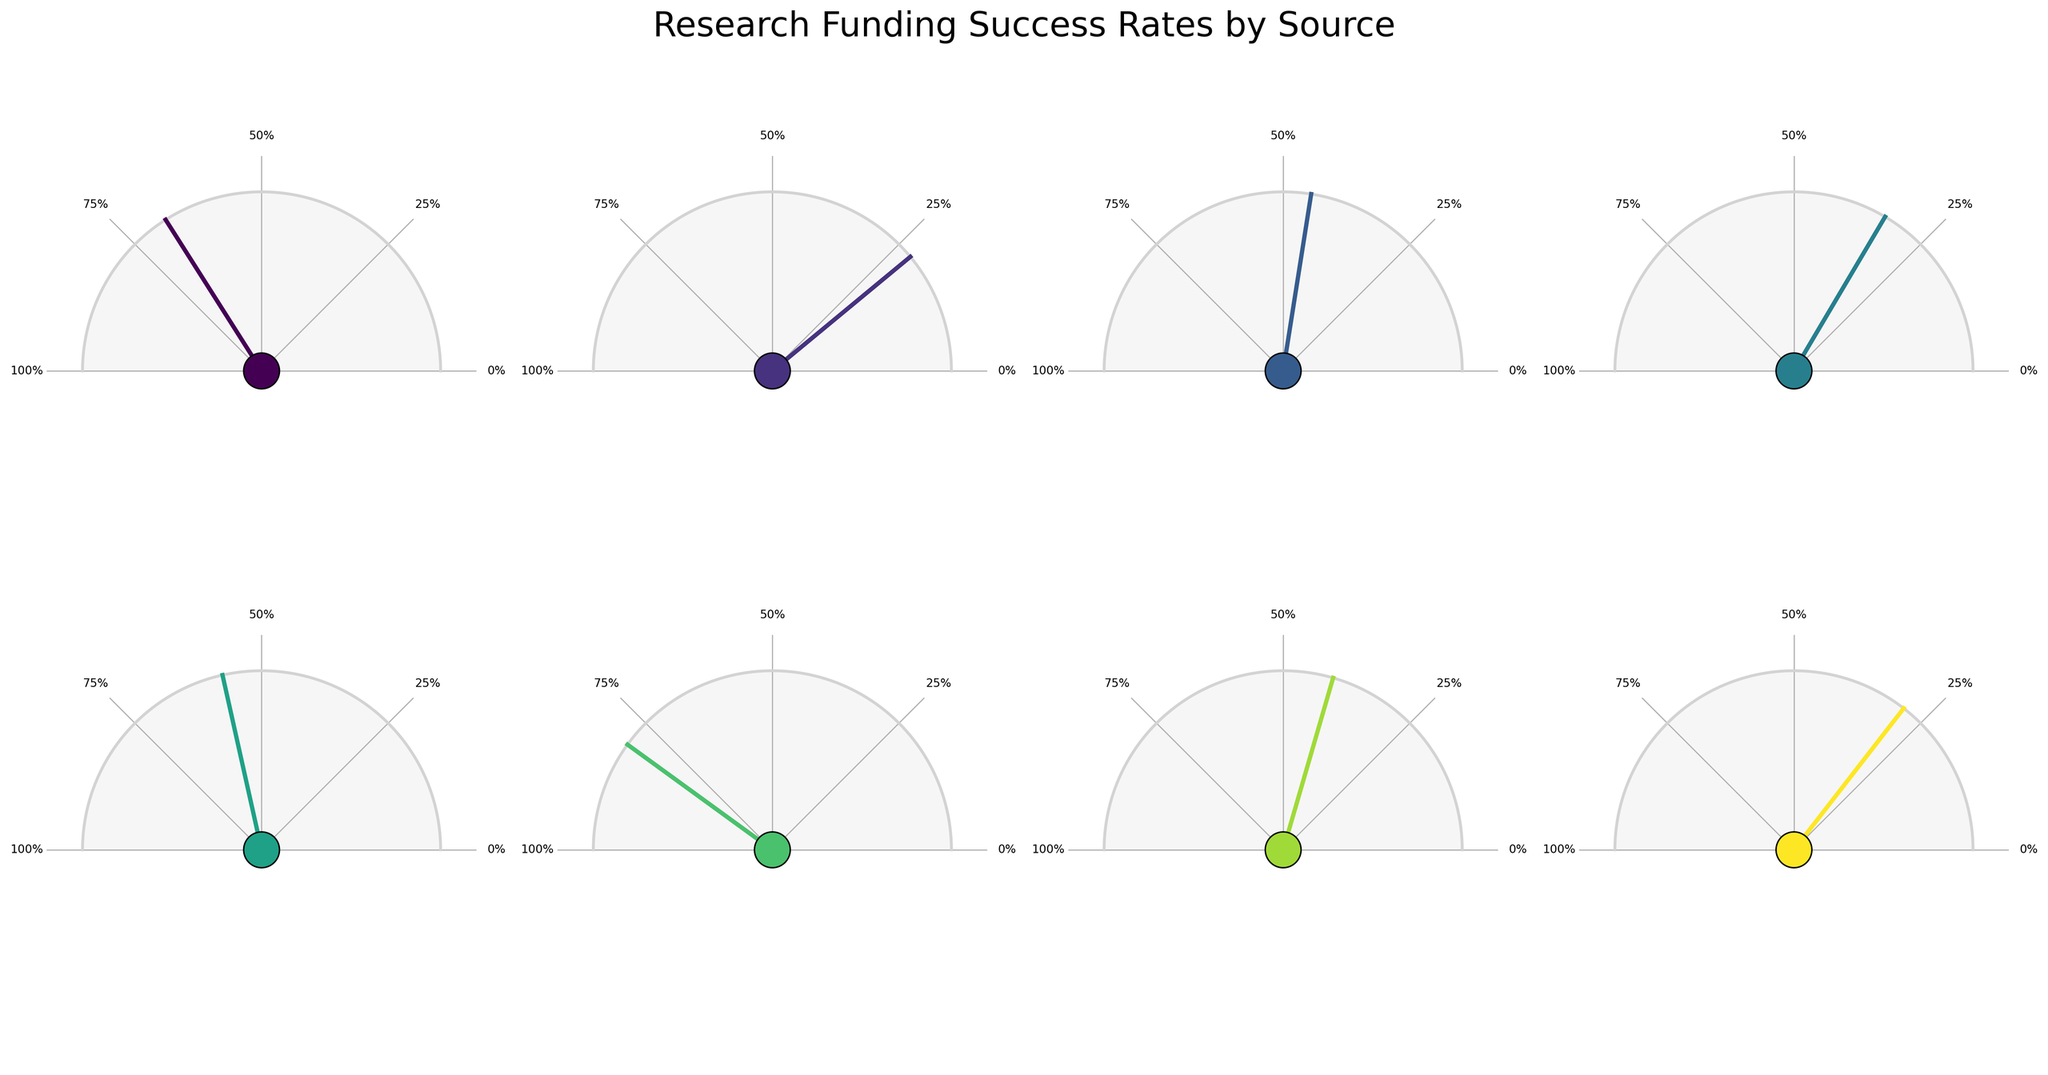What's the title of the figure? The title of a figure is usually positioned prominently at the top to give an overview of what the data represents. Here, the title is placed above the subplots.
Answer: Research Funding Success Rates by Source How many funding sources are represented in the gauge charts? Each gauge chart represents a different funding source. By counting the individual charts, we see 8 different gauges.
Answer: 8 Which funding source has the highest success rate in securing research funding? By observing the charts and comparing the percentage values, the highest success rate is indicated by the gauge that reaches the closest to 100%.
Answer: University Internal Grants What is the success rate for the National Science Foundation (NSF)? The NSF success rate in the gauge chart is marked near the 68% tick mark and labeled next to the center circle.
Answer: 68% What is the average success rate across all funding sources? Summing all the success rates (68 + 22 + 45 + 33 + 57 + 80 + 41 + 29) gives 375. Dividing by the number of sources (8) gives an average.
Answer: 46.875% Which funding source has the lowest success rate, and what is that rate? From examining the gauge charts, NIH has the lowest needle position and labeled rate of 22%.
Answer: NIH, 22% How does the success rate for Industry Partnerships compare to Private Foundations? By examining each gauge, Industry Partnerships have a rate of 57%, and Private Foundations have a rate of 41%, making Industry Partnerships higher.
Answer: Industry Partnerships have a higher success rate than Private Foundations What is the combined success rate of Department of Energy (DOE) and DARPA? Summing the success rates of DOE (45) and DARPA (29) gives a combined rate.
Answer: 74% What proportion of funding sources have a success rate of above 50%? Enumerating the sources with >50% success: NSF (68%), Industry Partnerships (57%), University Internal Grants (80%). Out of 8 total, this means 3/8 sources are above 50%.
Answer: 3 out of 8 (or 37.5%) In the gauge chart for the European Research Council (ERC), what is the value and color of the needle? The ERC gauge has a needle labeled at 33%, and the needle color typically follows the color mapping shown in the figure, likely a shade from the viridis colormap.
Answer: 33%, viridis shade 